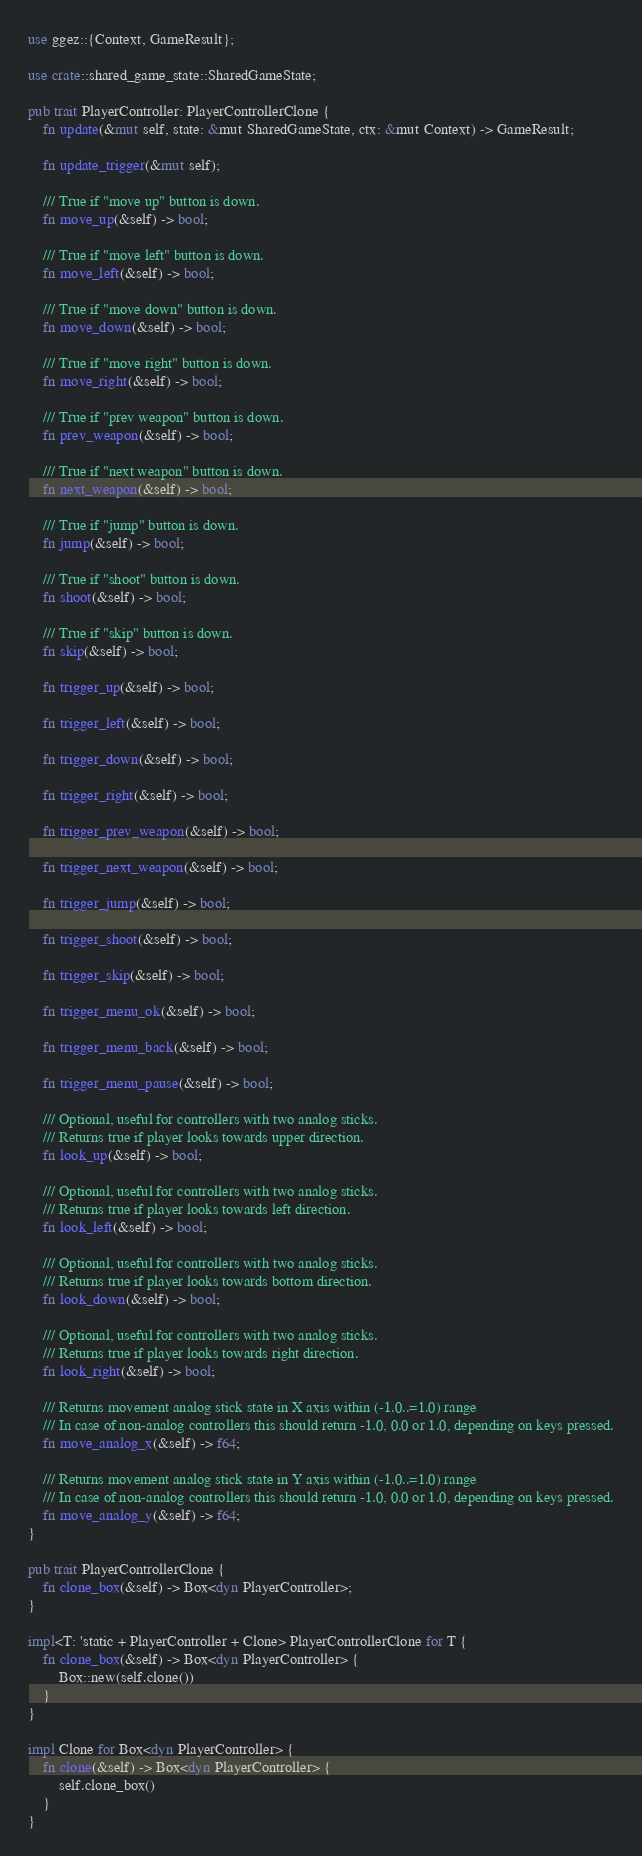Convert code to text. <code><loc_0><loc_0><loc_500><loc_500><_Rust_>use ggez::{Context, GameResult};

use crate::shared_game_state::SharedGameState;

pub trait PlayerController: PlayerControllerClone {
    fn update(&mut self, state: &mut SharedGameState, ctx: &mut Context) -> GameResult;

    fn update_trigger(&mut self);

    /// True if "move up" button is down.
    fn move_up(&self) -> bool;

    /// True if "move left" button is down.
    fn move_left(&self) -> bool;

    /// True if "move down" button is down.
    fn move_down(&self) -> bool;

    /// True if "move right" button is down.
    fn move_right(&self) -> bool;

    /// True if "prev weapon" button is down.
    fn prev_weapon(&self) -> bool;

    /// True if "next weapon" button is down.
    fn next_weapon(&self) -> bool;

    /// True if "jump" button is down.
    fn jump(&self) -> bool;

    /// True if "shoot" button is down.
    fn shoot(&self) -> bool;

    /// True if "skip" button is down.
    fn skip(&self) -> bool;

    fn trigger_up(&self) -> bool;

    fn trigger_left(&self) -> bool;

    fn trigger_down(&self) -> bool;

    fn trigger_right(&self) -> bool;

    fn trigger_prev_weapon(&self) -> bool;

    fn trigger_next_weapon(&self) -> bool;

    fn trigger_jump(&self) -> bool;

    fn trigger_shoot(&self) -> bool;

    fn trigger_skip(&self) -> bool;

    fn trigger_menu_ok(&self) -> bool;

    fn trigger_menu_back(&self) -> bool;

    fn trigger_menu_pause(&self) -> bool;

    /// Optional, useful for controllers with two analog sticks.
    /// Returns true if player looks towards upper direction.
    fn look_up(&self) -> bool;

    /// Optional, useful for controllers with two analog sticks.
    /// Returns true if player looks towards left direction.
    fn look_left(&self) -> bool;

    /// Optional, useful for controllers with two analog sticks.
    /// Returns true if player looks towards bottom direction.
    fn look_down(&self) -> bool;

    /// Optional, useful for controllers with two analog sticks.
    /// Returns true if player looks towards right direction.
    fn look_right(&self) -> bool;

    /// Returns movement analog stick state in X axis within (-1.0..=1.0) range
    /// In case of non-analog controllers this should return -1.0, 0.0 or 1.0, depending on keys pressed.
    fn move_analog_x(&self) -> f64;

    /// Returns movement analog stick state in Y axis within (-1.0..=1.0) range
    /// In case of non-analog controllers this should return -1.0, 0.0 or 1.0, depending on keys pressed.
    fn move_analog_y(&self) -> f64;
}

pub trait PlayerControllerClone {
    fn clone_box(&self) -> Box<dyn PlayerController>;
}

impl<T: 'static + PlayerController + Clone> PlayerControllerClone for T {
    fn clone_box(&self) -> Box<dyn PlayerController> {
        Box::new(self.clone())
    }
}

impl Clone for Box<dyn PlayerController> {
    fn clone(&self) -> Box<dyn PlayerController> {
        self.clone_box()
    }
}
</code> 